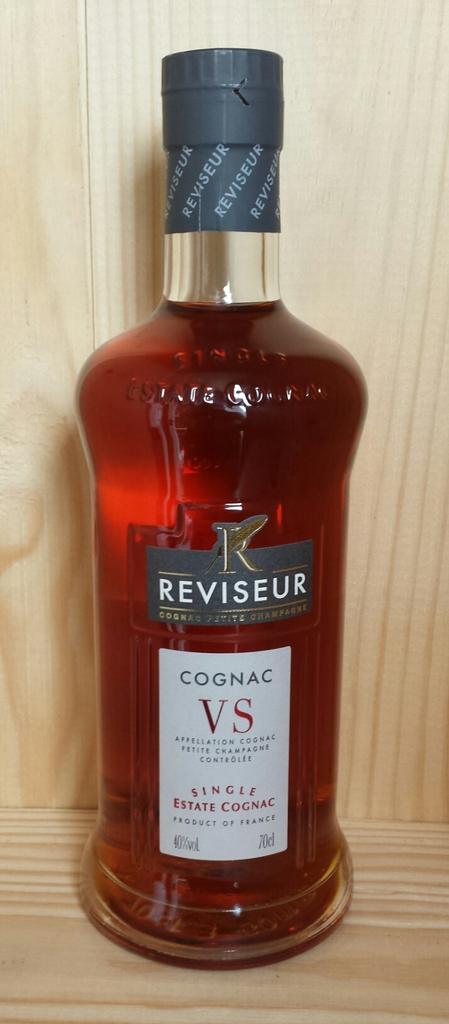Does cognac taste good?
Give a very brief answer. Unanswerable. What kind of alcohol is this?
Ensure brevity in your answer.  Cognac. 